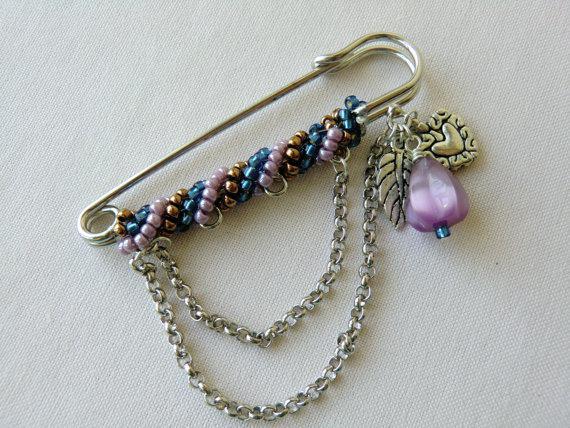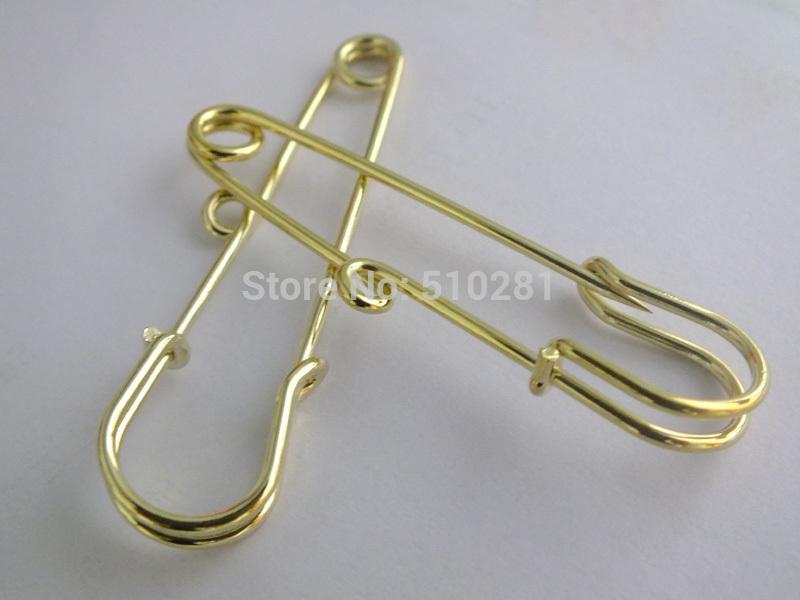The first image is the image on the left, the second image is the image on the right. Assess this claim about the two images: "The right image shows only one decorated pin.". Correct or not? Answer yes or no. No. 